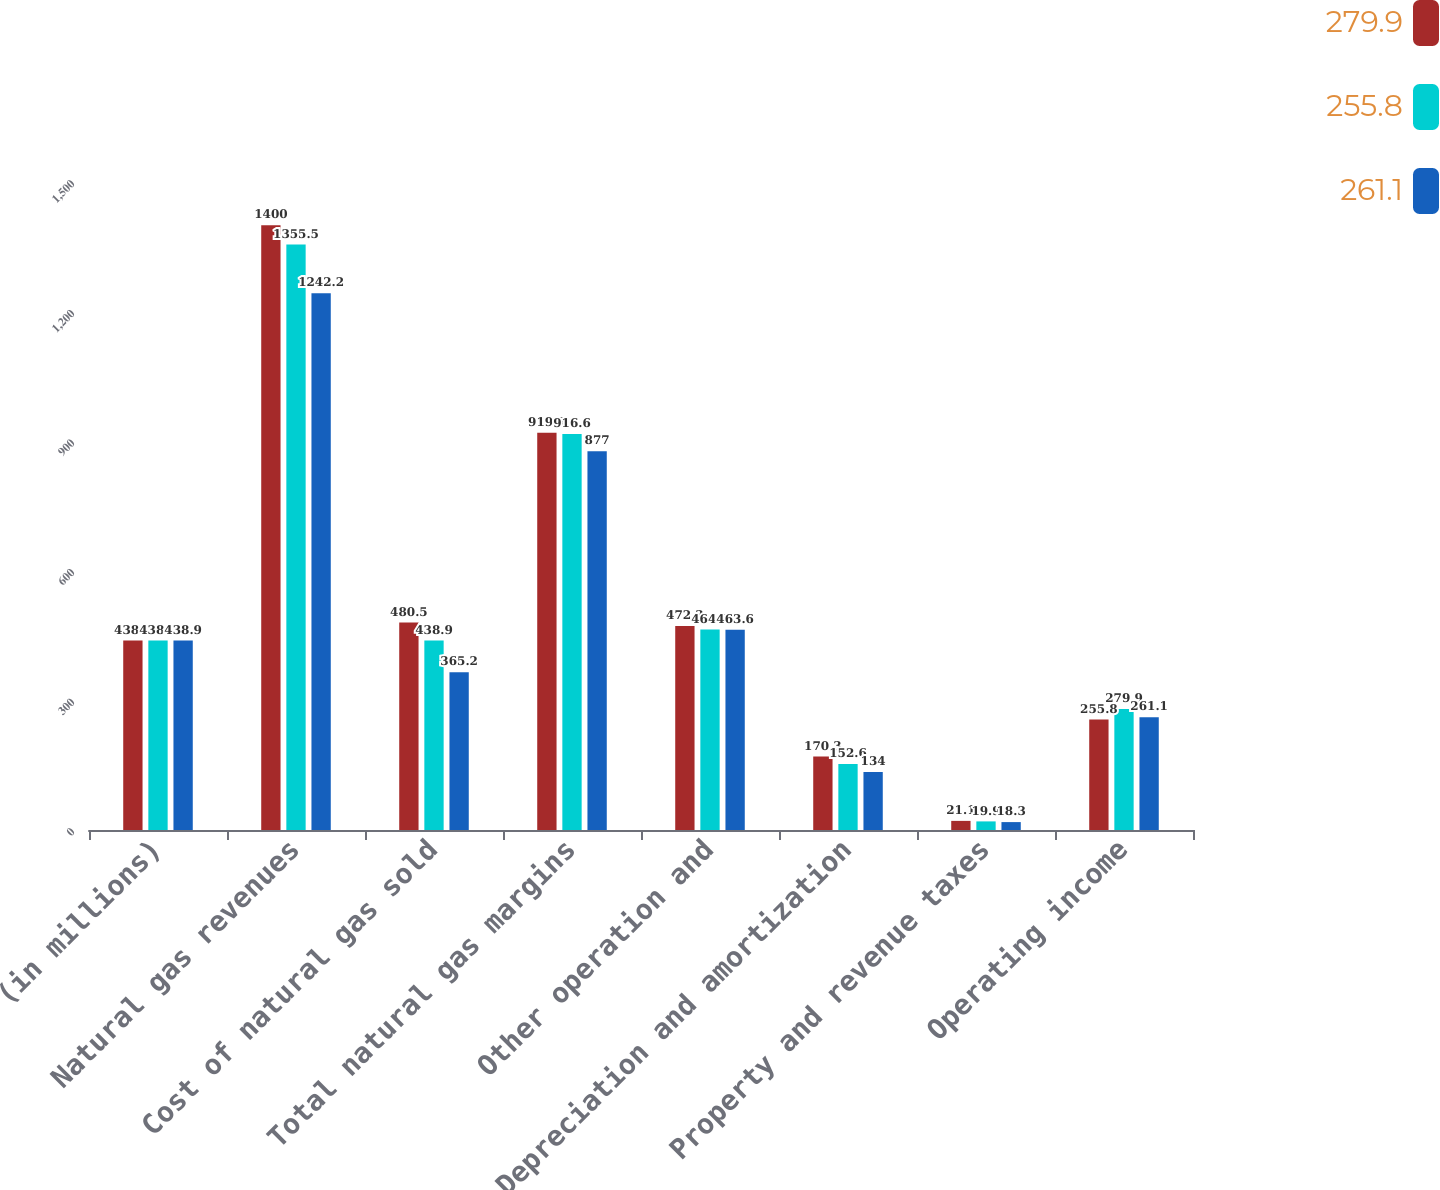Convert chart. <chart><loc_0><loc_0><loc_500><loc_500><stacked_bar_chart><ecel><fcel>(in millions)<fcel>Natural gas revenues<fcel>Cost of natural gas sold<fcel>Total natural gas margins<fcel>Other operation and<fcel>Depreciation and amortization<fcel>Property and revenue taxes<fcel>Operating income<nl><fcel>279.9<fcel>438.9<fcel>1400<fcel>480.5<fcel>919.5<fcel>472.3<fcel>170.3<fcel>21.1<fcel>255.8<nl><fcel>255.8<fcel>438.9<fcel>1355.5<fcel>438.9<fcel>916.6<fcel>464.2<fcel>152.6<fcel>19.9<fcel>279.9<nl><fcel>261.1<fcel>438.9<fcel>1242.2<fcel>365.2<fcel>877<fcel>463.6<fcel>134<fcel>18.3<fcel>261.1<nl></chart> 